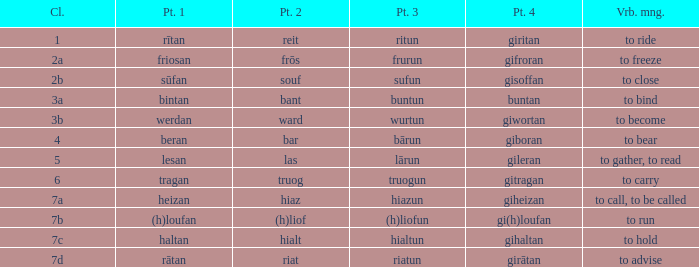What is the verb meaning of the word with part 3 "sufun"? To close. 